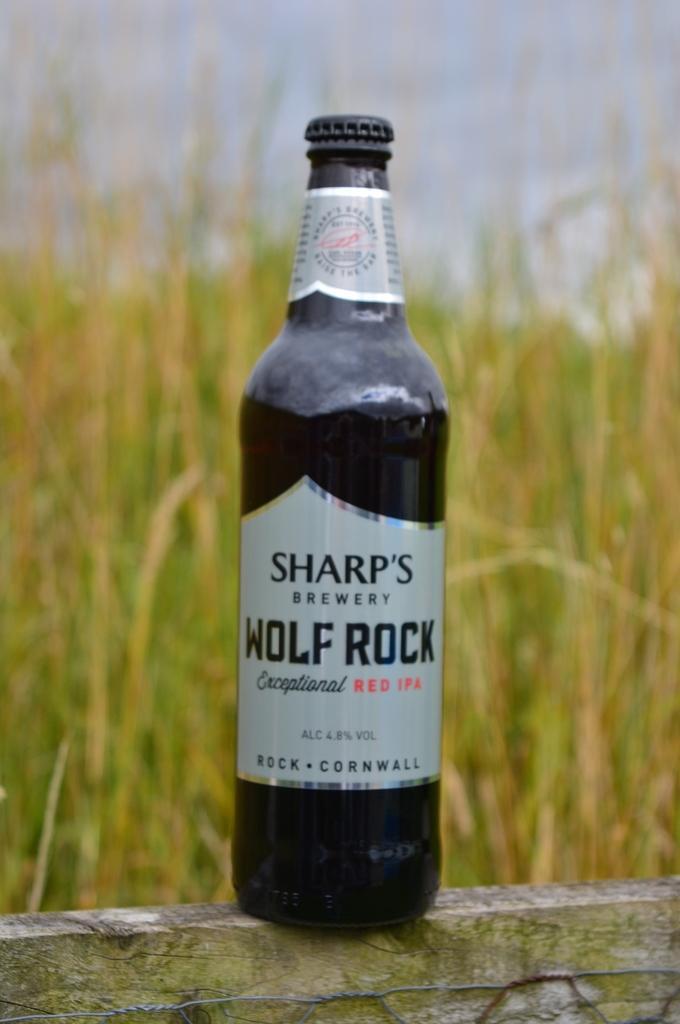In one or two sentences, can you explain what this image depicts? In this image there is a glass bottle with labels to it , and in the background there is grass,sky. 